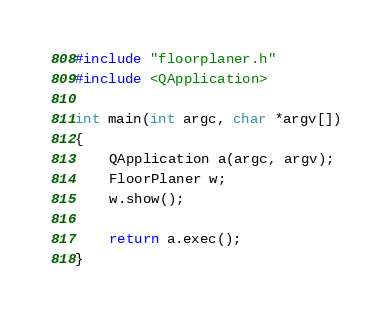Convert code to text. <code><loc_0><loc_0><loc_500><loc_500><_C++_>#include "floorplaner.h"
#include <QApplication>

int main(int argc, char *argv[])
{
    QApplication a(argc, argv);
    FloorPlaner w;
    w.show();

    return a.exec();
}
</code> 